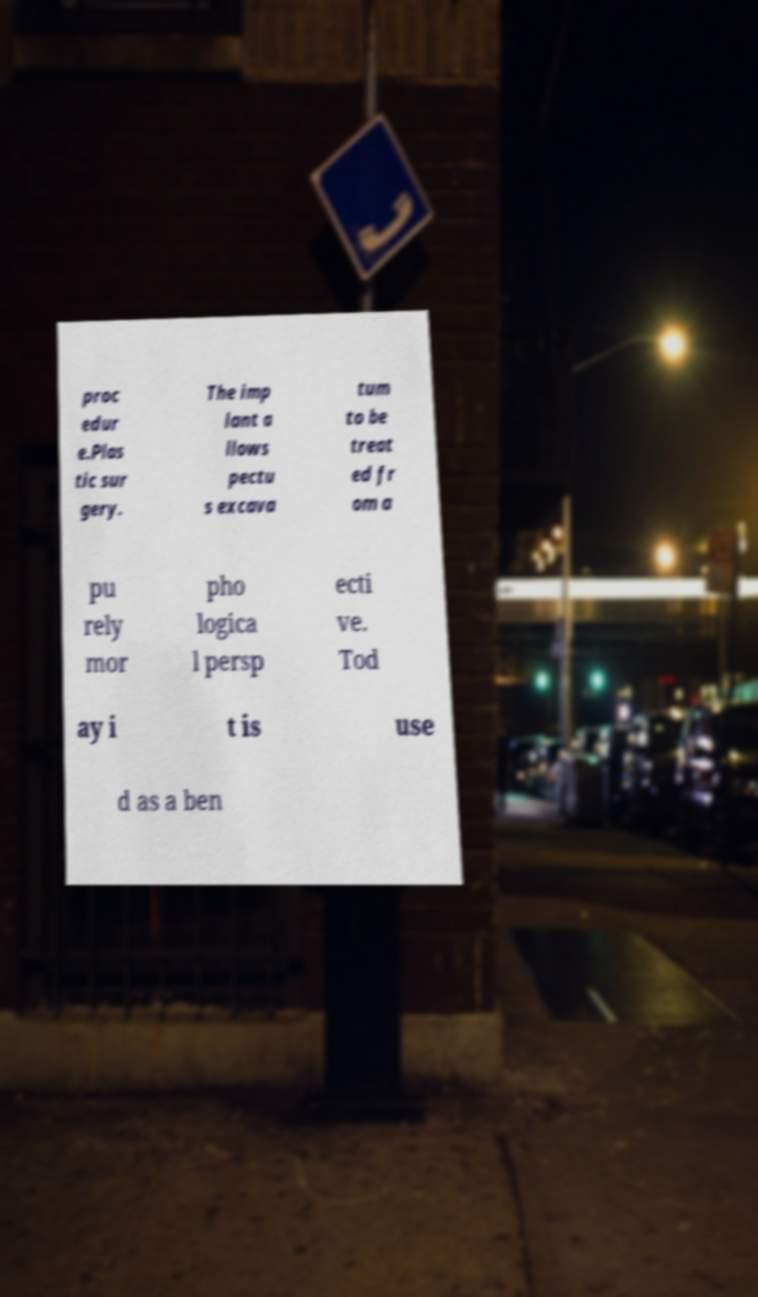Please identify and transcribe the text found in this image. proc edur e.Plas tic sur gery. The imp lant a llows pectu s excava tum to be treat ed fr om a pu rely mor pho logica l persp ecti ve. Tod ay i t is use d as a ben 